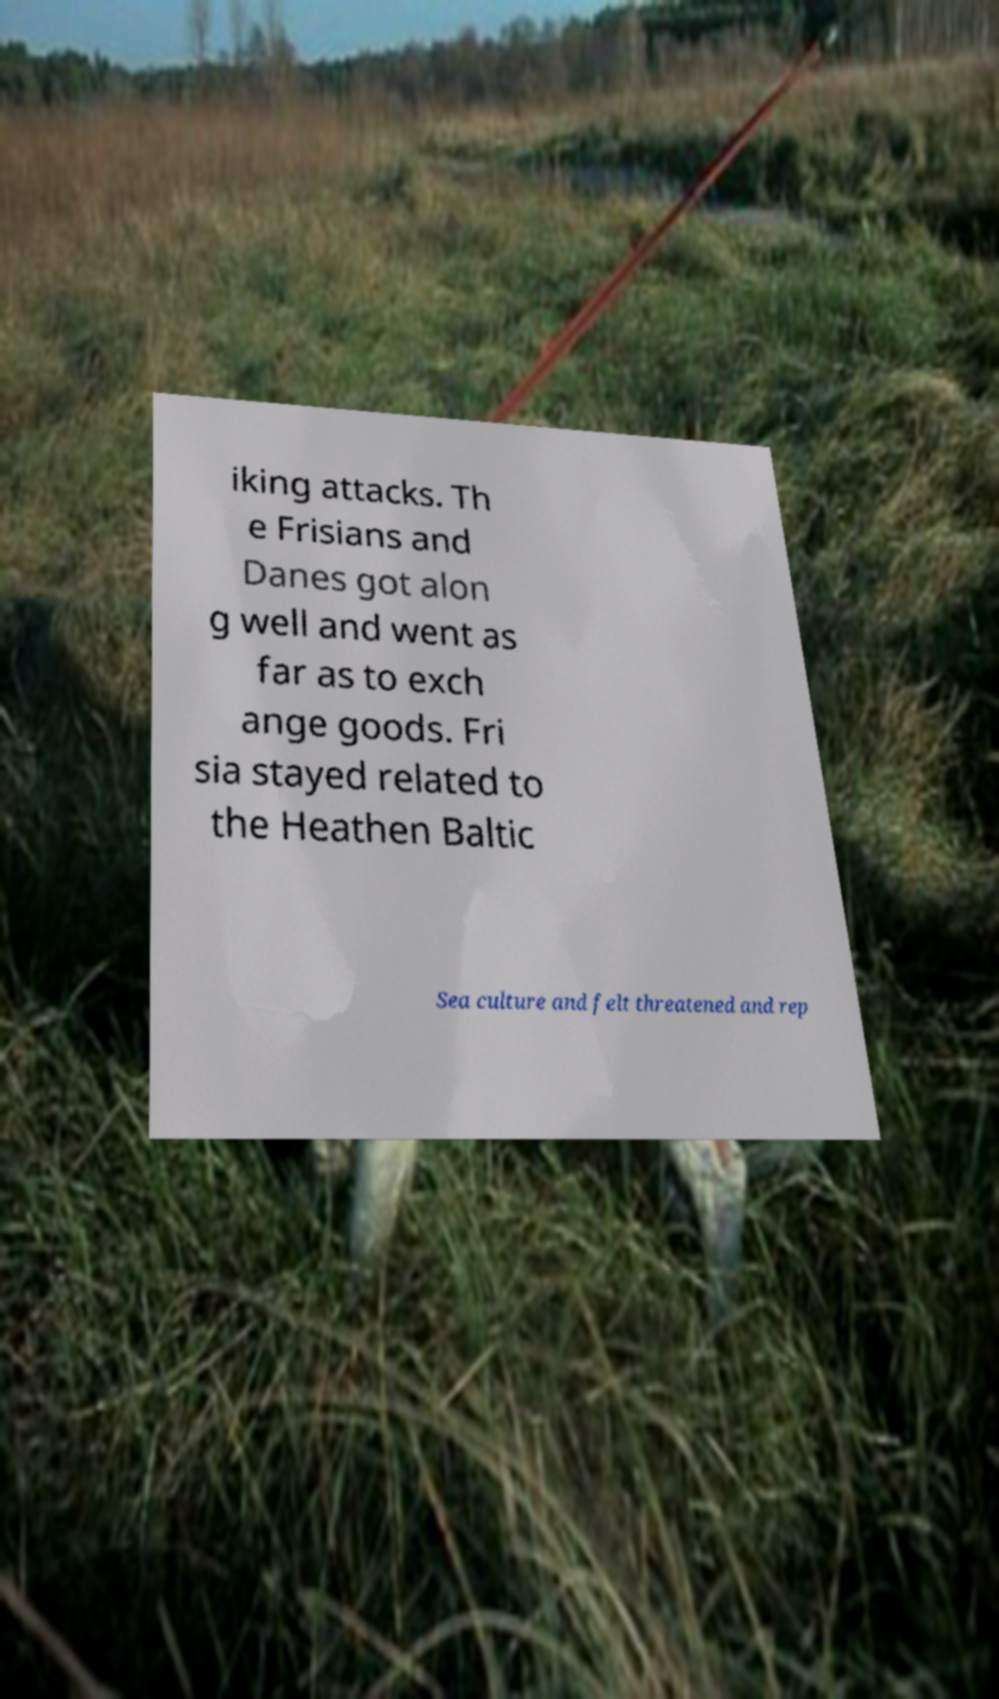Can you accurately transcribe the text from the provided image for me? iking attacks. Th e Frisians and Danes got alon g well and went as far as to exch ange goods. Fri sia stayed related to the Heathen Baltic Sea culture and felt threatened and rep 